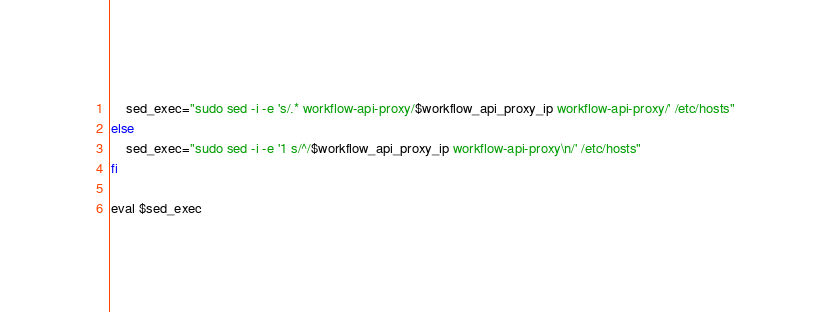Convert code to text. <code><loc_0><loc_0><loc_500><loc_500><_Bash_>    sed_exec="sudo sed -i -e 's/.* workflow-api-proxy/$workflow_api_proxy_ip workflow-api-proxy/' /etc/hosts"
else 
    sed_exec="sudo sed -i -e '1 s/^/$workflow_api_proxy_ip workflow-api-proxy\n/' /etc/hosts"
fi

eval $sed_exec
</code> 